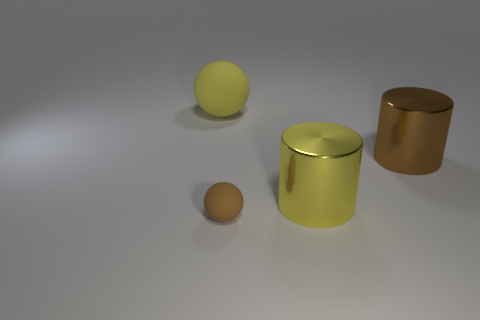There is a cylinder that is the same color as the small sphere; what is its material?
Give a very brief answer. Metal. What number of small brown things are the same shape as the big brown metallic object?
Your response must be concise. 0. Does the big brown cylinder have the same material as the sphere that is in front of the big yellow sphere?
Keep it short and to the point. No. There is a ball that is the same size as the brown cylinder; what is its material?
Provide a succinct answer. Rubber. Are there any yellow metallic cylinders of the same size as the yellow rubber object?
Your answer should be compact. Yes. There is a brown object that is the same size as the yellow rubber sphere; what shape is it?
Keep it short and to the point. Cylinder. How many other objects are the same color as the tiny matte sphere?
Offer a very short reply. 1. There is a big thing that is on the right side of the brown rubber sphere and to the left of the brown metallic thing; what is its shape?
Your response must be concise. Cylinder. There is a large object to the left of the yellow object in front of the big yellow sphere; are there any spheres in front of it?
Your answer should be very brief. Yes. What number of other objects are the same material as the large brown object?
Keep it short and to the point. 1. 